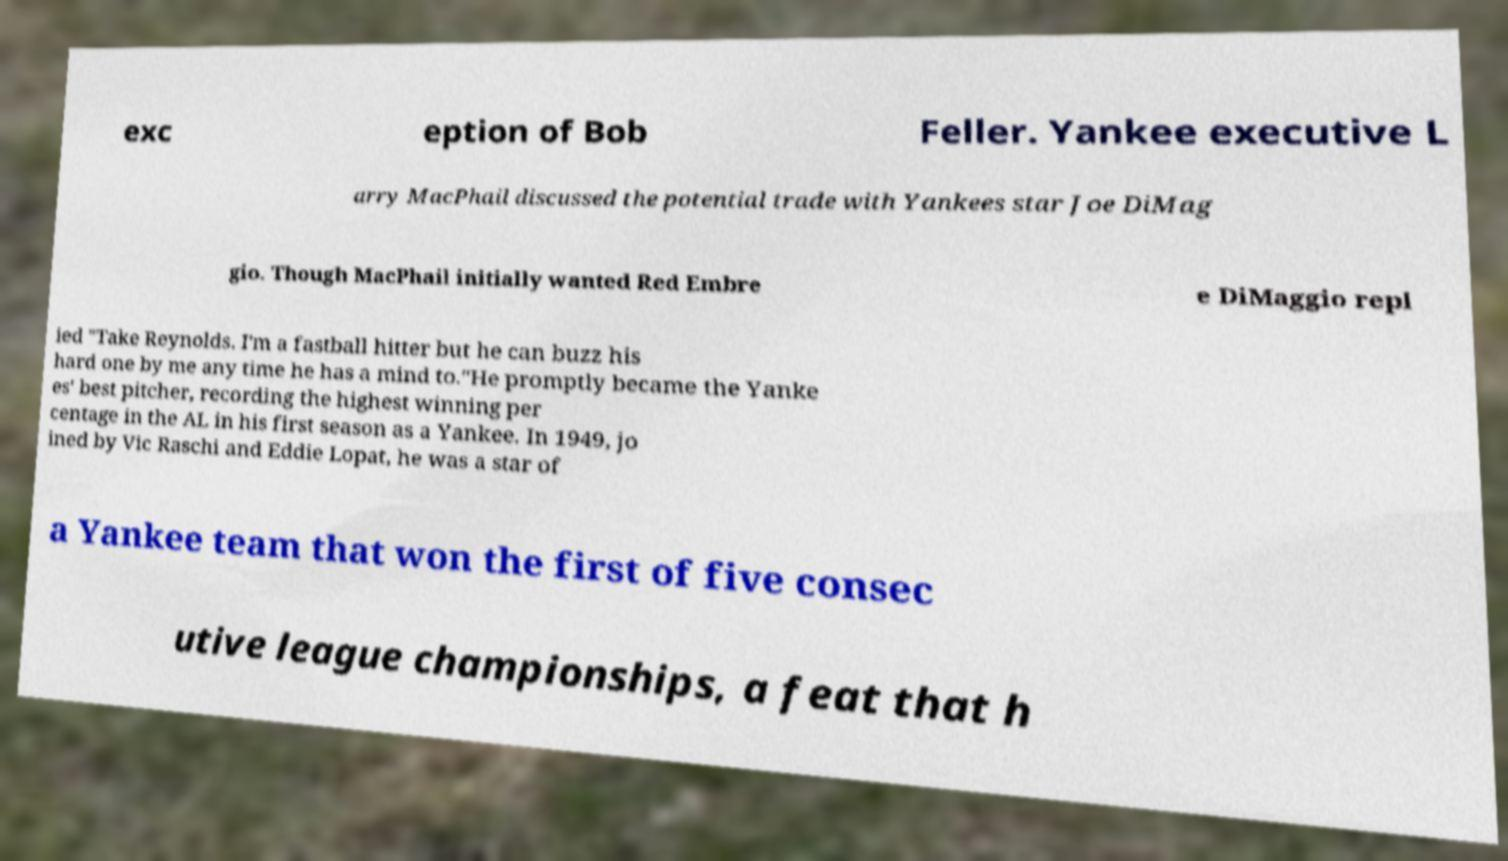What messages or text are displayed in this image? I need them in a readable, typed format. exc eption of Bob Feller. Yankee executive L arry MacPhail discussed the potential trade with Yankees star Joe DiMag gio. Though MacPhail initially wanted Red Embre e DiMaggio repl ied "Take Reynolds. I'm a fastball hitter but he can buzz his hard one by me any time he has a mind to."He promptly became the Yanke es' best pitcher, recording the highest winning per centage in the AL in his first season as a Yankee. In 1949, jo ined by Vic Raschi and Eddie Lopat, he was a star of a Yankee team that won the first of five consec utive league championships, a feat that h 